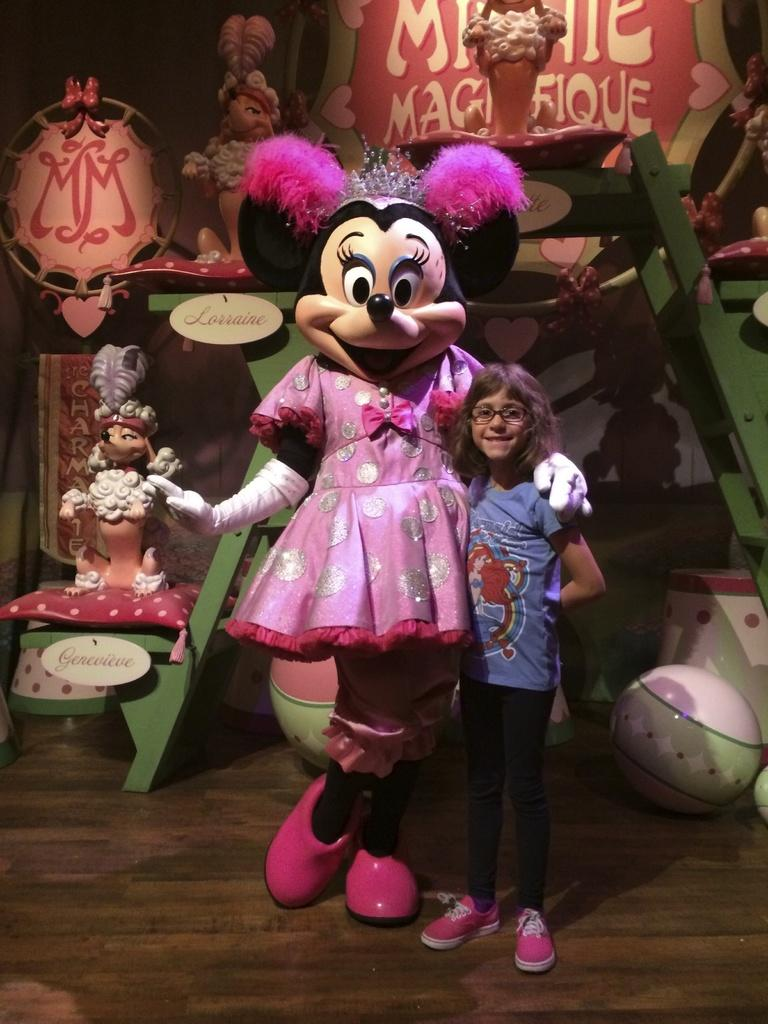Who is the main subject in the image? There is a girl standing in the center of the image. What object can be seen near the girl? There is a toy in the image. What can be seen in the background of the image? There are toys, a ladder, and boxes in the background of the image. What is visible at the bottom of the image? There is a floor visible at the bottom of the image. What type of note is the girl holding in the image? There is no note visible in the image; the girl is not holding anything. 